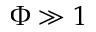Convert formula to latex. <formula><loc_0><loc_0><loc_500><loc_500>\Phi \gg 1</formula> 